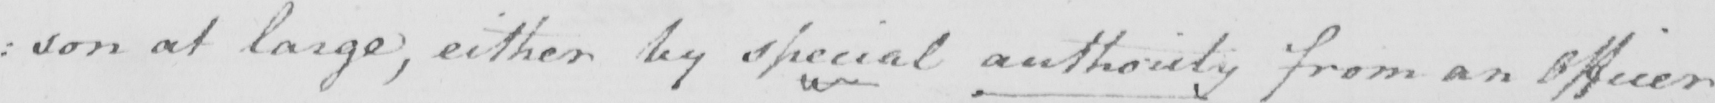Transcribe the text shown in this historical manuscript line. : son at large , either by special authority from an Officer 